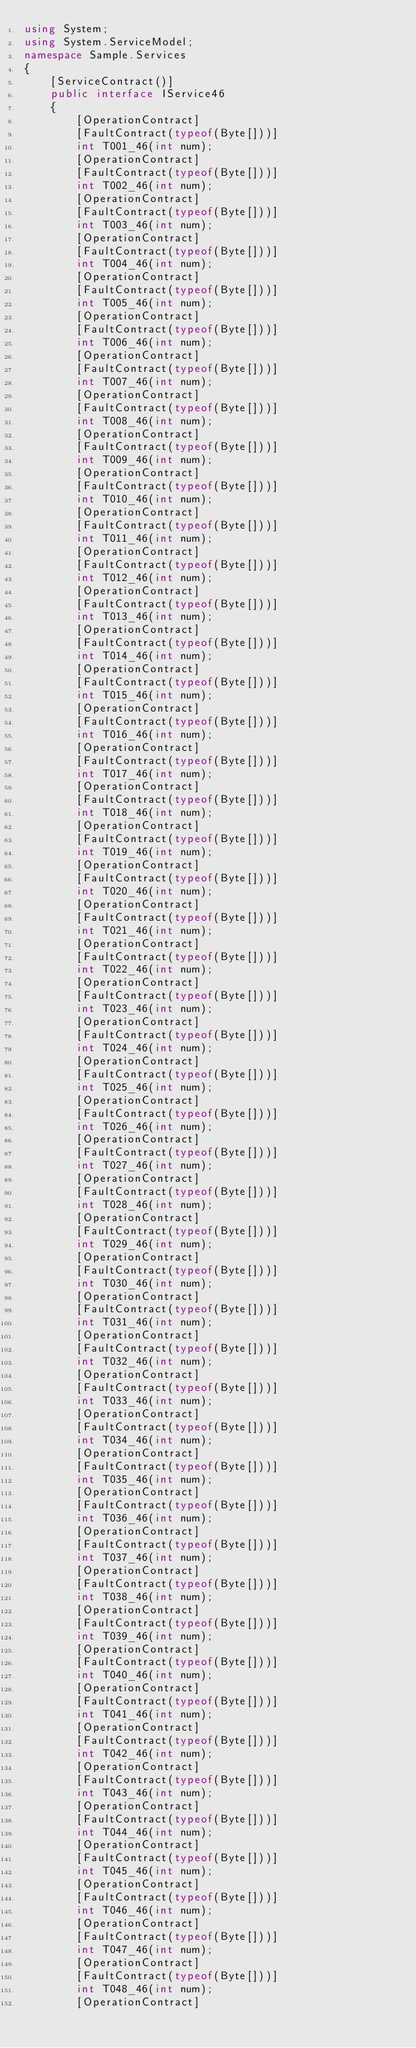<code> <loc_0><loc_0><loc_500><loc_500><_C#_>using System;
using System.ServiceModel;
namespace Sample.Services
{
    [ServiceContract()]
    public interface IService46
    {
        [OperationContract]
        [FaultContract(typeof(Byte[]))]
        int T001_46(int num);
        [OperationContract]
        [FaultContract(typeof(Byte[]))]
        int T002_46(int num);
        [OperationContract]
        [FaultContract(typeof(Byte[]))]
        int T003_46(int num);
        [OperationContract]
        [FaultContract(typeof(Byte[]))]
        int T004_46(int num);
        [OperationContract]
        [FaultContract(typeof(Byte[]))]
        int T005_46(int num);
        [OperationContract]
        [FaultContract(typeof(Byte[]))]
        int T006_46(int num);
        [OperationContract]
        [FaultContract(typeof(Byte[]))]
        int T007_46(int num);
        [OperationContract]
        [FaultContract(typeof(Byte[]))]
        int T008_46(int num);
        [OperationContract]
        [FaultContract(typeof(Byte[]))]
        int T009_46(int num);
        [OperationContract]
        [FaultContract(typeof(Byte[]))]
        int T010_46(int num);
        [OperationContract]
        [FaultContract(typeof(Byte[]))]
        int T011_46(int num);
        [OperationContract]
        [FaultContract(typeof(Byte[]))]
        int T012_46(int num);
        [OperationContract]
        [FaultContract(typeof(Byte[]))]
        int T013_46(int num);
        [OperationContract]
        [FaultContract(typeof(Byte[]))]
        int T014_46(int num);
        [OperationContract]
        [FaultContract(typeof(Byte[]))]
        int T015_46(int num);
        [OperationContract]
        [FaultContract(typeof(Byte[]))]
        int T016_46(int num);
        [OperationContract]
        [FaultContract(typeof(Byte[]))]
        int T017_46(int num);
        [OperationContract]
        [FaultContract(typeof(Byte[]))]
        int T018_46(int num);
        [OperationContract]
        [FaultContract(typeof(Byte[]))]
        int T019_46(int num);
        [OperationContract]
        [FaultContract(typeof(Byte[]))]
        int T020_46(int num);
        [OperationContract]
        [FaultContract(typeof(Byte[]))]
        int T021_46(int num);
        [OperationContract]
        [FaultContract(typeof(Byte[]))]
        int T022_46(int num);
        [OperationContract]
        [FaultContract(typeof(Byte[]))]
        int T023_46(int num);
        [OperationContract]
        [FaultContract(typeof(Byte[]))]
        int T024_46(int num);
        [OperationContract]
        [FaultContract(typeof(Byte[]))]
        int T025_46(int num);
        [OperationContract]
        [FaultContract(typeof(Byte[]))]
        int T026_46(int num);
        [OperationContract]
        [FaultContract(typeof(Byte[]))]
        int T027_46(int num);
        [OperationContract]
        [FaultContract(typeof(Byte[]))]
        int T028_46(int num);
        [OperationContract]
        [FaultContract(typeof(Byte[]))]
        int T029_46(int num);
        [OperationContract]
        [FaultContract(typeof(Byte[]))]
        int T030_46(int num);
        [OperationContract]
        [FaultContract(typeof(Byte[]))]
        int T031_46(int num);
        [OperationContract]
        [FaultContract(typeof(Byte[]))]
        int T032_46(int num);
        [OperationContract]
        [FaultContract(typeof(Byte[]))]
        int T033_46(int num);
        [OperationContract]
        [FaultContract(typeof(Byte[]))]
        int T034_46(int num);
        [OperationContract]
        [FaultContract(typeof(Byte[]))]
        int T035_46(int num);
        [OperationContract]
        [FaultContract(typeof(Byte[]))]
        int T036_46(int num);
        [OperationContract]
        [FaultContract(typeof(Byte[]))]
        int T037_46(int num);
        [OperationContract]
        [FaultContract(typeof(Byte[]))]
        int T038_46(int num);
        [OperationContract]
        [FaultContract(typeof(Byte[]))]
        int T039_46(int num);
        [OperationContract]
        [FaultContract(typeof(Byte[]))]
        int T040_46(int num);
        [OperationContract]
        [FaultContract(typeof(Byte[]))]
        int T041_46(int num);
        [OperationContract]
        [FaultContract(typeof(Byte[]))]
        int T042_46(int num);
        [OperationContract]
        [FaultContract(typeof(Byte[]))]
        int T043_46(int num);
        [OperationContract]
        [FaultContract(typeof(Byte[]))]
        int T044_46(int num);
        [OperationContract]
        [FaultContract(typeof(Byte[]))]
        int T045_46(int num);
        [OperationContract]
        [FaultContract(typeof(Byte[]))]
        int T046_46(int num);
        [OperationContract]
        [FaultContract(typeof(Byte[]))]
        int T047_46(int num);
        [OperationContract]
        [FaultContract(typeof(Byte[]))]
        int T048_46(int num);
        [OperationContract]</code> 